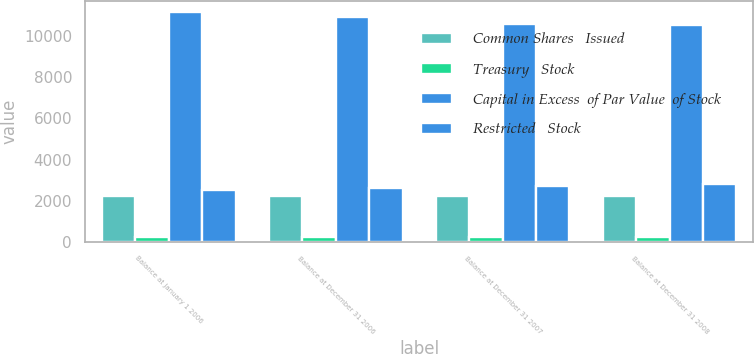<chart> <loc_0><loc_0><loc_500><loc_500><stacked_bar_chart><ecel><fcel>Balance at January 1 2006<fcel>Balance at December 31 2006<fcel>Balance at December 31 2007<fcel>Balance at December 31 2008<nl><fcel>Common Shares   Issued<fcel>2205<fcel>2205<fcel>2205<fcel>2205<nl><fcel>Treasury   Stock<fcel>248<fcel>238<fcel>226<fcel>226<nl><fcel>Capital in Excess  of Par Value  of Stock<fcel>11168<fcel>10927<fcel>10584<fcel>10566<nl><fcel>Restricted   Stock<fcel>2528<fcel>2626<fcel>2722<fcel>2828<nl></chart> 